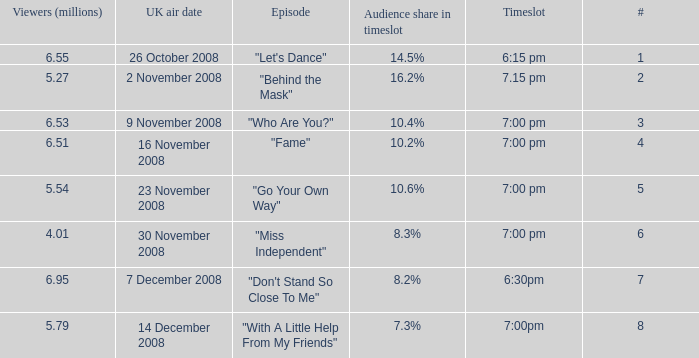Can you give me this table as a dict? {'header': ['Viewers (millions)', 'UK air date', 'Episode', 'Audience share in timeslot', 'Timeslot', '#'], 'rows': [['6.55', '26 October 2008', '"Let\'s Dance"', '14.5%', '6:15 pm', '1'], ['5.27', '2 November 2008', '"Behind the Mask"', '16.2%', '7.15 pm', '2'], ['6.53', '9 November 2008', '"Who Are You?"', '10.4%', '7:00 pm', '3'], ['6.51', '16 November 2008', '"Fame"', '10.2%', '7:00 pm', '4'], ['5.54', '23 November 2008', '"Go Your Own Way"', '10.6%', '7:00 pm', '5'], ['4.01', '30 November 2008', '"Miss Independent"', '8.3%', '7:00 pm', '6'], ['6.95', '7 December 2008', '"Don\'t Stand So Close To Me"', '8.2%', '6:30pm', '7'], ['5.79', '14 December 2008', '"With A Little Help From My Friends"', '7.3%', '7:00pm', '8']]} Name the total number of viewers for audience share in timeslot for 10.2% 1.0. 